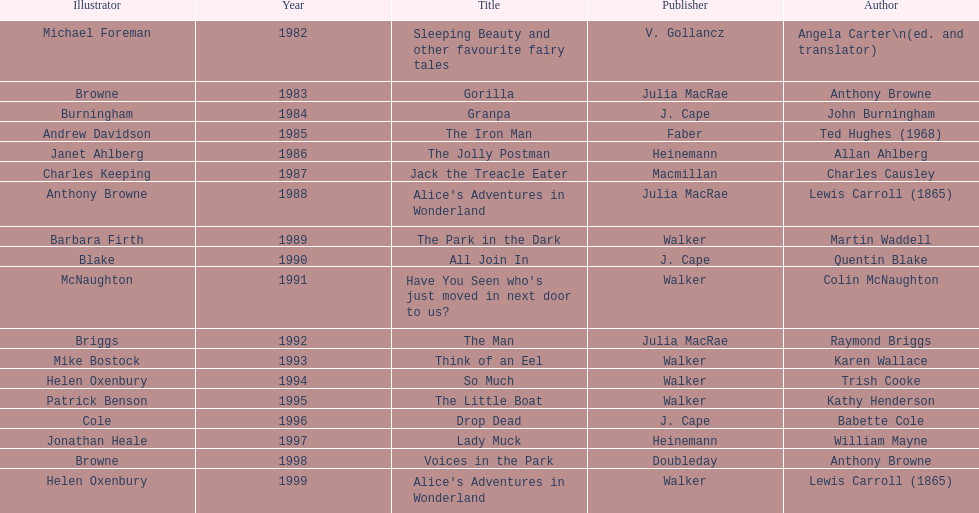What is the only title listed for 1999? Alice's Adventures in Wonderland. 